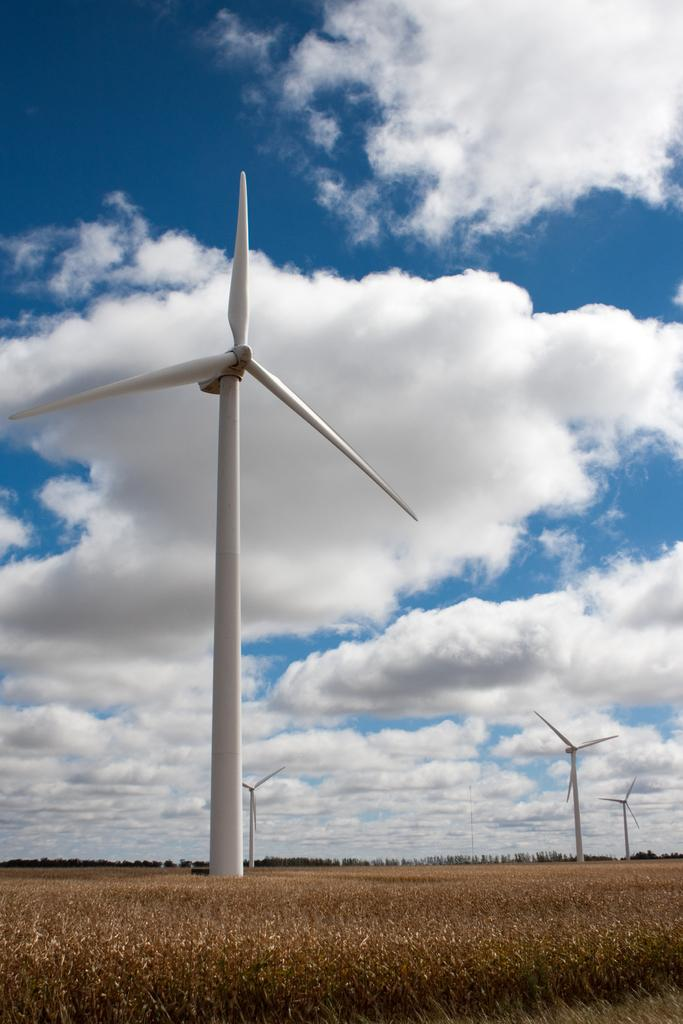What is the main feature of the image? There are many wind turbines in the image. What type of landscape can be seen at the bottom of the image? There is farmland at the bottom of the image. What can be seen in the background of the image? There are trees in the background of the image. What is visible at the top of the image? The sky is visible at the top of the image. What is the condition of the sky in the image? Clouds are present in the sky. Can you tell me how many vases are placed on the wind turbines in the image? There are no vases present on the wind turbines in the image. What color are the eyes of the trees in the background? There are no eyes present on the trees in the image, as trees do not have eyes. 